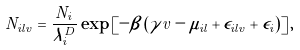Convert formula to latex. <formula><loc_0><loc_0><loc_500><loc_500>N _ { i l v } = \frac { N _ { i } } { \lambda _ { i } ^ { D } } \exp \left [ - \beta \left ( \gamma v - \mu _ { i l } + \epsilon _ { i l v } + \epsilon _ { i } \right ) \right ] ,</formula> 